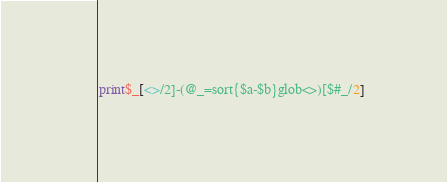Convert code to text. <code><loc_0><loc_0><loc_500><loc_500><_Perl_>print$_[<>/2]-(@_=sort{$a-$b}glob<>)[$#_/2]</code> 